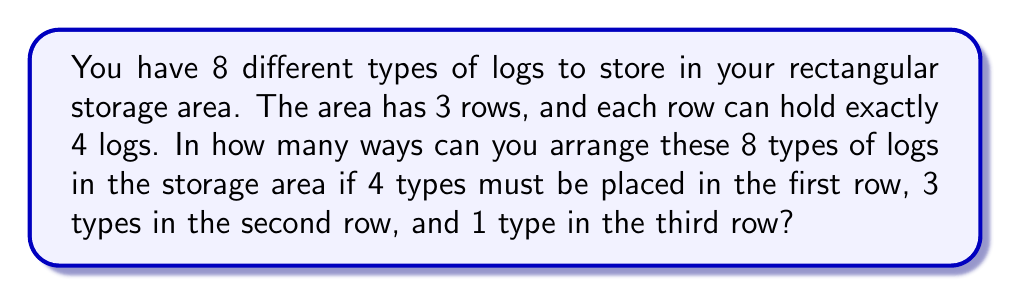Could you help me with this problem? Let's break this down step-by-step:

1) First, we need to choose which 4 types of logs will go in the first row:
   $${8 \choose 4} = \frac{8!}{4!(8-4)!} = \frac{8!}{4!4!} = 70$$

2) For the first row, we need to arrange these 4 types:
   $$4! = 24$$

3) For the second row, we have 4 types left, and we need to choose 3:
   $${4 \choose 3} = \frac{4!}{3!(4-3)!} = \frac{4!}{3!1!} = 4$$

4) We then need to arrange these 3 types in the second row:
   $$3! = 6$$

5) For the third row, we only have 1 type left, so there's only 1 way to place it.

6) By the multiplication principle, the total number of ways is:
   $$70 \times 24 \times 4 \times 6 \times 1 = 40,320$$
Answer: 40,320 